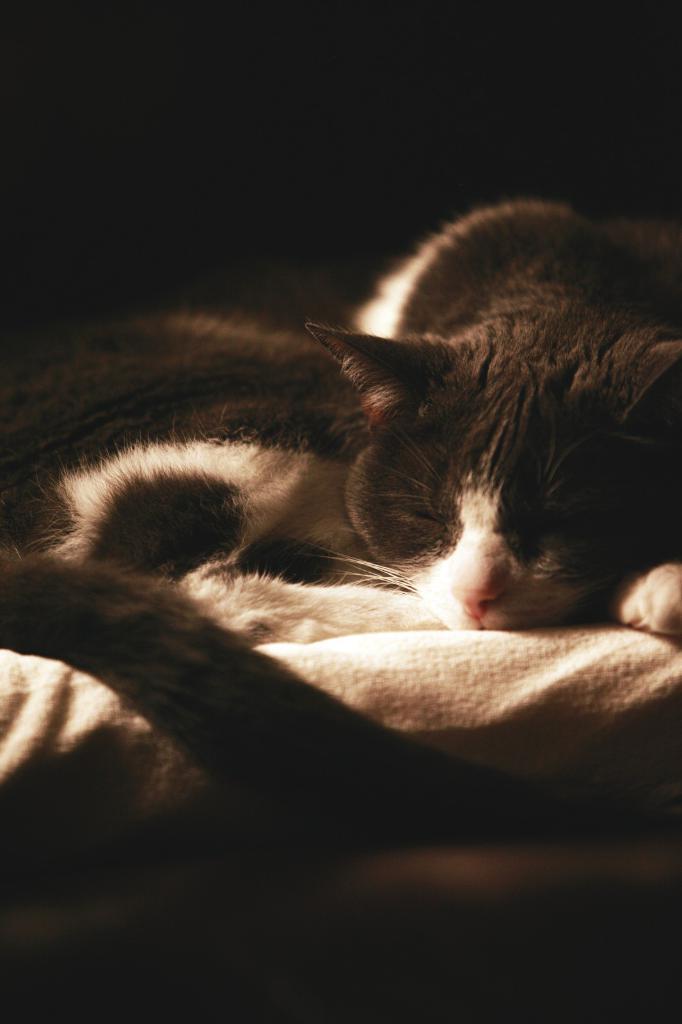In one or two sentences, can you explain what this image depicts? In this image I can see a cat is lying on the bed. This image is taken may be during night. 